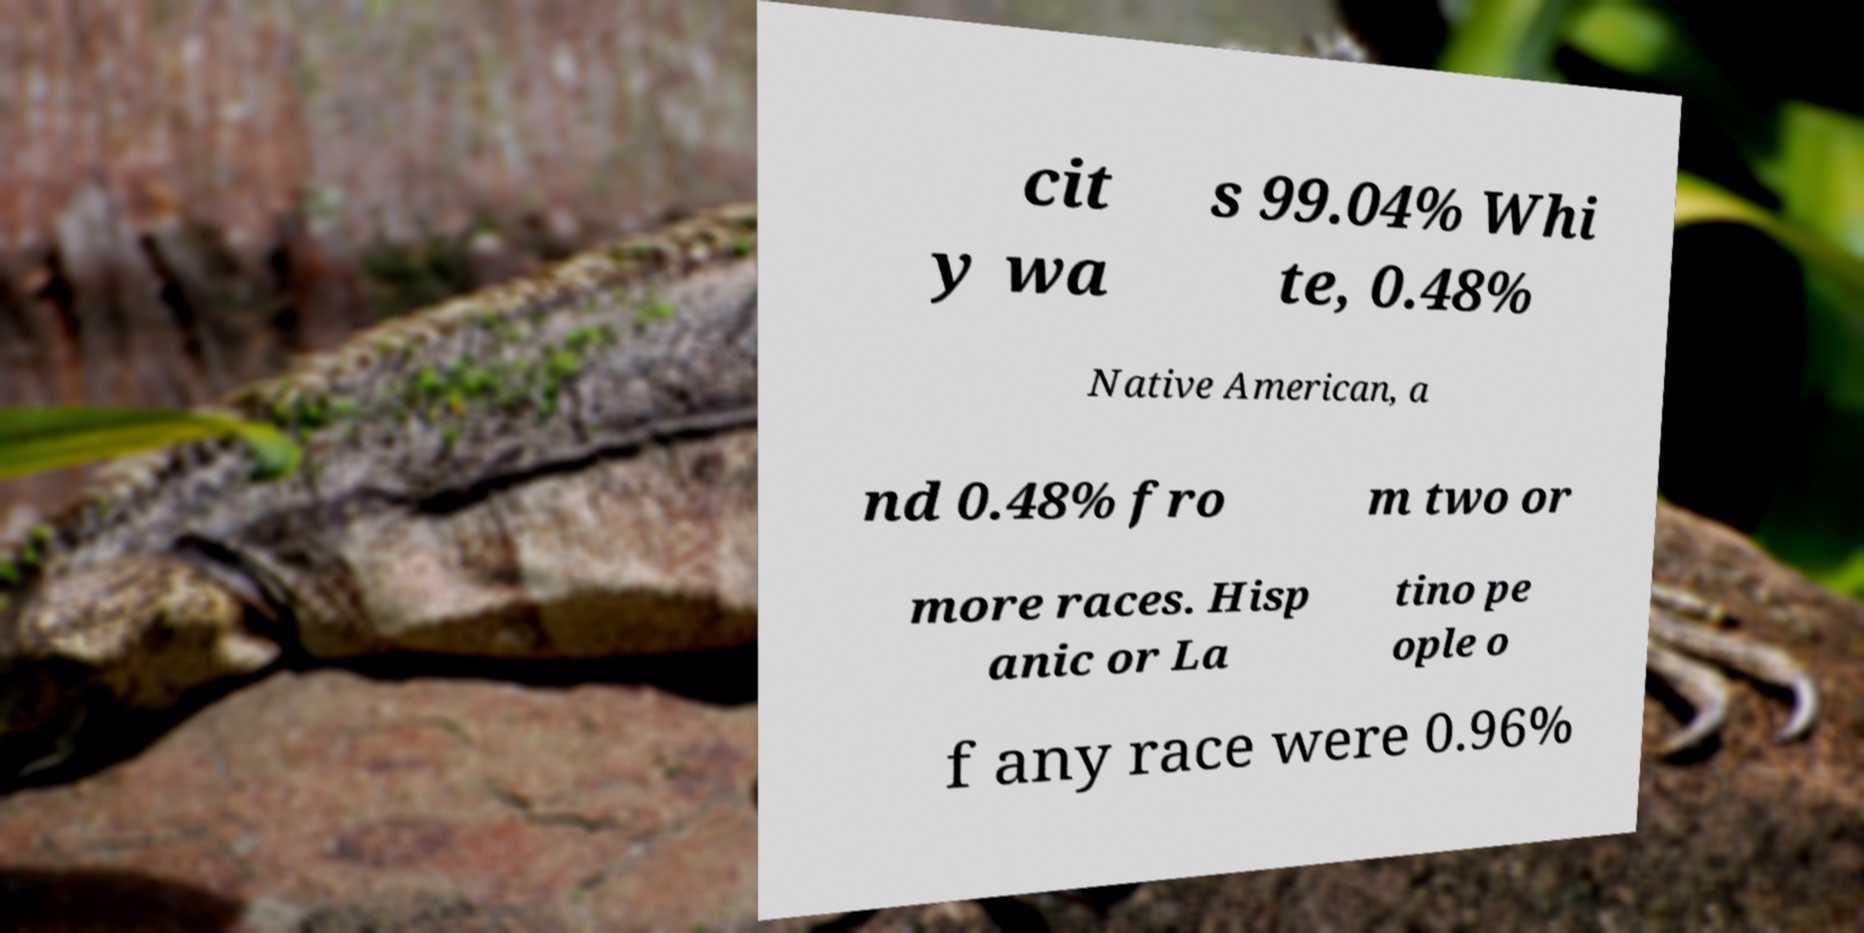I need the written content from this picture converted into text. Can you do that? cit y wa s 99.04% Whi te, 0.48% Native American, a nd 0.48% fro m two or more races. Hisp anic or La tino pe ople o f any race were 0.96% 